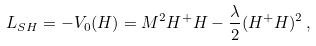<formula> <loc_0><loc_0><loc_500><loc_500>L _ { S H } = - V _ { 0 } ( H ) = M ^ { 2 } H ^ { + } H - \frac { \lambda } { 2 } ( H ^ { + } H ) ^ { 2 } \, ,</formula> 